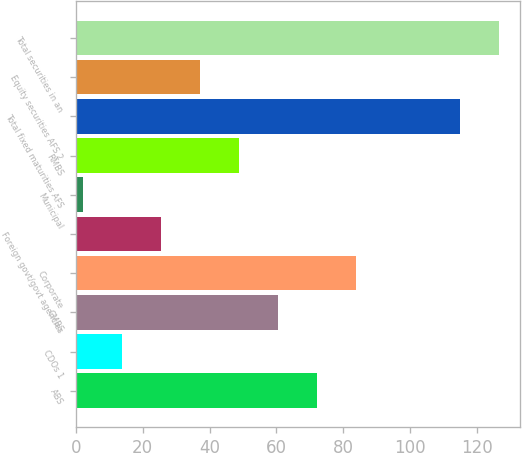Convert chart. <chart><loc_0><loc_0><loc_500><loc_500><bar_chart><fcel>ABS<fcel>CDOs 1<fcel>CMBS<fcel>Corporate<fcel>Foreign govt/govt agencies<fcel>Municipal<fcel>RMBS<fcel>Total fixed maturities AFS<fcel>Equity securities AFS 2<fcel>Total securities in an<nl><fcel>72.2<fcel>13.7<fcel>60.5<fcel>83.9<fcel>25.4<fcel>2<fcel>48.8<fcel>115<fcel>37.1<fcel>126.7<nl></chart> 